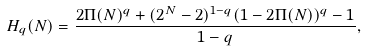<formula> <loc_0><loc_0><loc_500><loc_500>H _ { q } ( N ) = \frac { 2 \Pi ( N ) ^ { q } + ( 2 ^ { N } - 2 ) ^ { 1 - q } ( 1 - 2 \Pi ( N ) ) ^ { q } - 1 } { 1 - q } ,</formula> 